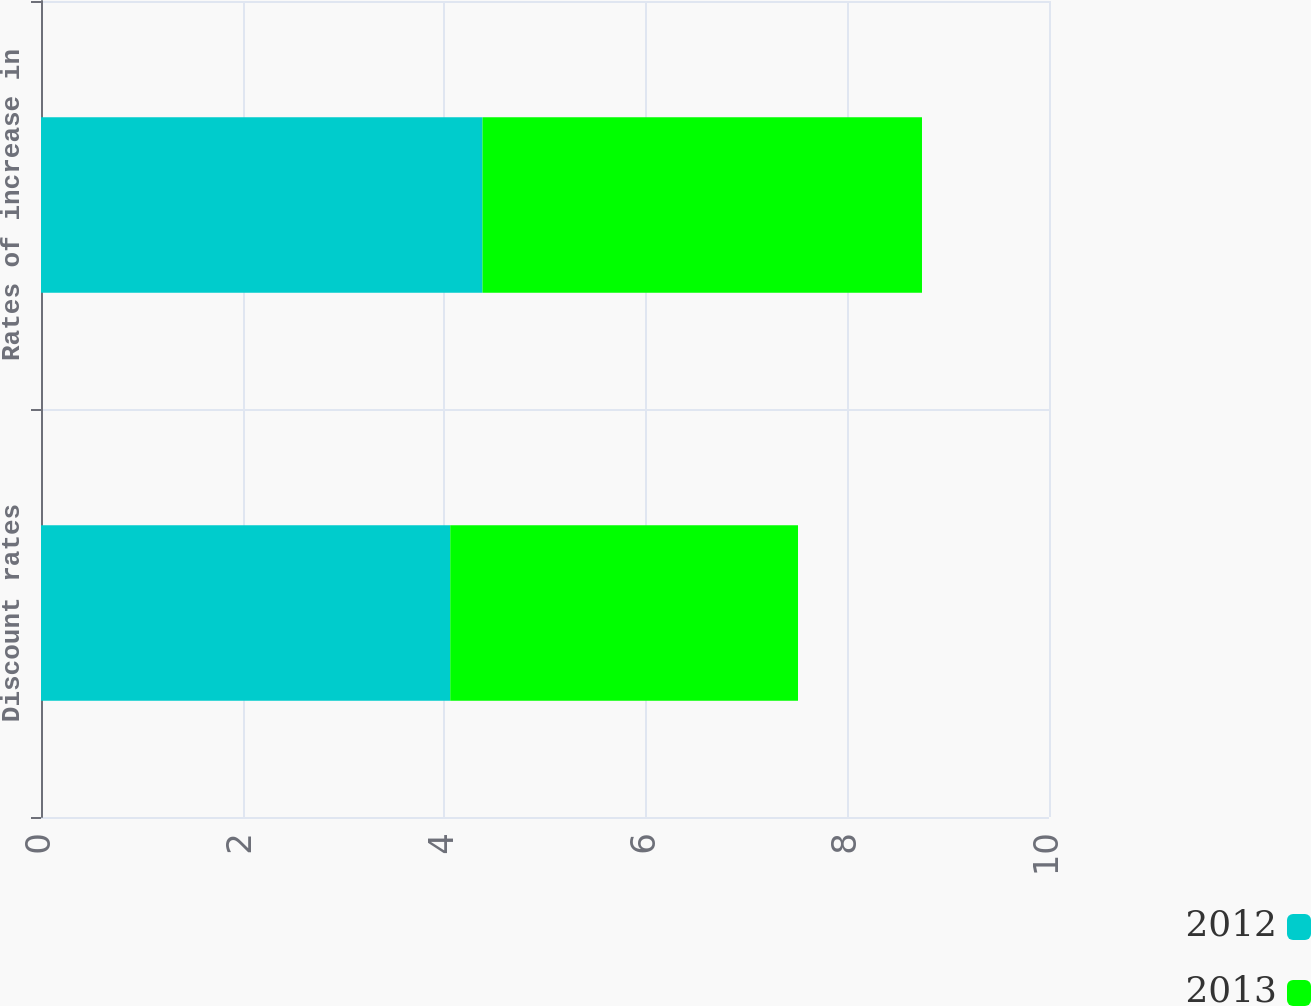Convert chart. <chart><loc_0><loc_0><loc_500><loc_500><stacked_bar_chart><ecel><fcel>Discount rates<fcel>Rates of increase in<nl><fcel>2012<fcel>4.06<fcel>4.38<nl><fcel>2013<fcel>3.45<fcel>4.36<nl></chart> 